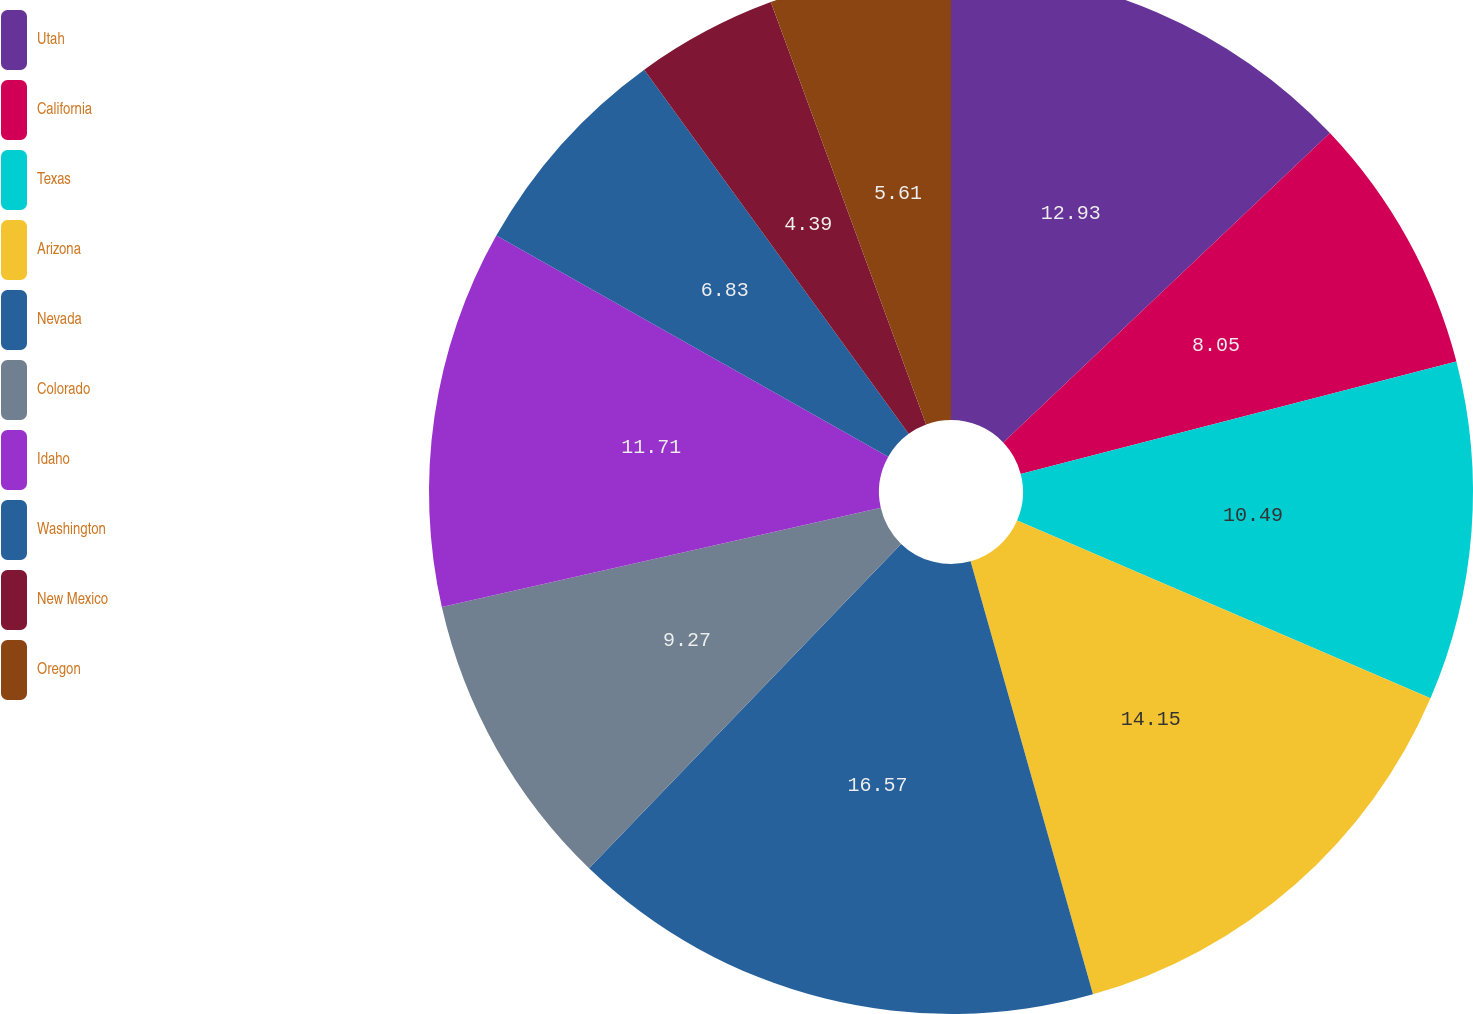Convert chart to OTSL. <chart><loc_0><loc_0><loc_500><loc_500><pie_chart><fcel>Utah<fcel>California<fcel>Texas<fcel>Arizona<fcel>Nevada<fcel>Colorado<fcel>Idaho<fcel>Washington<fcel>New Mexico<fcel>Oregon<nl><fcel>12.93%<fcel>8.05%<fcel>10.49%<fcel>14.15%<fcel>16.58%<fcel>9.27%<fcel>11.71%<fcel>6.83%<fcel>4.39%<fcel>5.61%<nl></chart> 